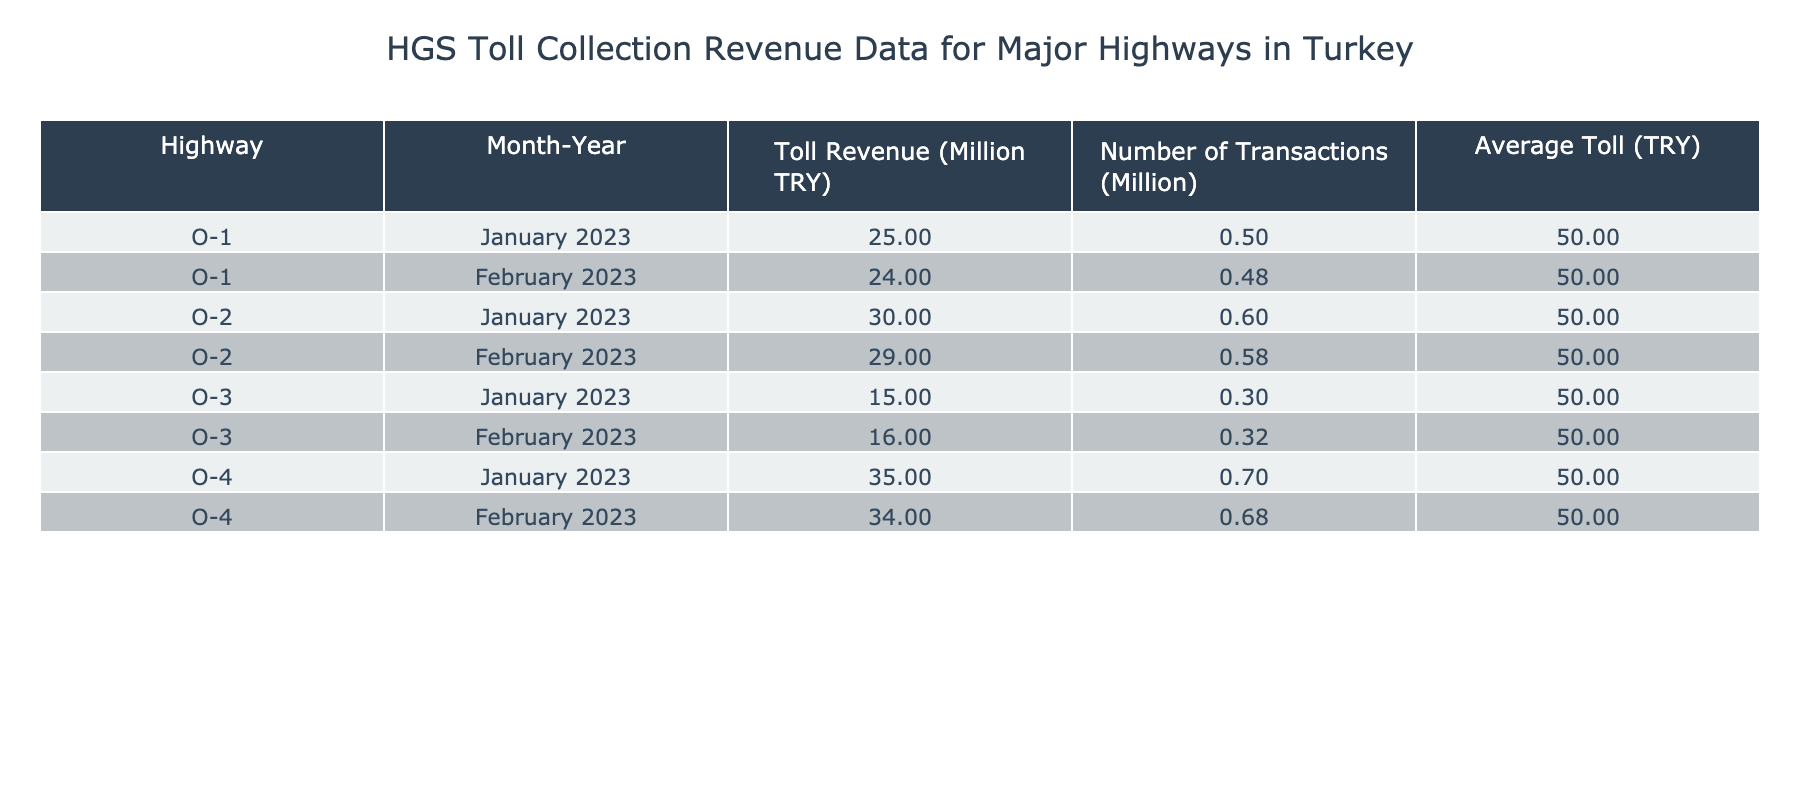What was the total toll revenue for Highway O-1 in January and February 2023? From the table, Highway O-1 has a toll revenue of 25,000,000 TRY in January and 24,000,000 TRY in February. Summing these amounts gives us 25,000,000 + 24,000,000 = 49,000,000 TRY.
Answer: 49,000,000 TRY What is the average number of transactions for Highway O-2 over the two months? The number of transactions for Highway O-2 is 600,000 in January and 580,000 in February. We first sum the transactions: 600,000 + 580,000 = 1,180,000. Then, we divide by 2 for the average: 1,180,000 / 2 = 590,000.
Answer: 590,000 transactions Is the average toll for Highway O-3 the same across both months? The average toll for Highway O-3 is listed as 50 TRY for both January and February, indicating consistency.
Answer: Yes Which highway had the highest toll revenue in February 2023? In February 2023, the toll revenues show that Highway O-4 had 34,000,000 TRY, which is higher compared to Highway O-1 (24,000,000) and O-2 (29,000,000). Thus, O-4 had the highest toll revenue.
Answer: Highway O-4 What is the difference in toll revenue between Highway O-4 and Highway O-1 in January 2023? Highway O-4 had a revenue of 35,000,000 TRY, while Highway O-1 had 25,000,000 TRY in January 2023. The difference is calculated as 35,000,000 - 25,000,000 = 10,000,000 TRY.
Answer: 10,000,000 TRY Did the number of transactions for Highway O-3 increase from January to February 2023? The number of transactions for Highway O-3 were 300,000 in January and increased to 320,000 in February, indicating growth.
Answer: Yes What is the total toll revenue collected for all highways in January 2023? To find the total toll revenue for all highways in January 2023, we sum the revenues: 25,000,000 (O-1) + 30,000,000 (O-2) + 15,000,000 (O-3) + 35,000,000 (O-4) = 105,000,000 TRY.
Answer: 105,000,000 TRY How many total transactions occurred on Highway O-1 across both months? Highway O-1 had 500,000 transactions in January and 480,000 in February. Adding these gives us 500,000 + 480,000 = 980,000 transactions in total.
Answer: 980,000 transactions Which month saw higher overall toll revenue for all highways combined? For January: 25,000,000 (O-1) + 30,000,000 (O-2) + 15,000,000 (O-3) + 35,000,000 (O-4) = 105,000,000. For February: 24,000,000 (O-1) + 29,000,000 (O-2) + 16,000,000 (O-3) + 34,000,000 (O-4) = 103,000,000. Therefore, January had higher revenue.
Answer: January 